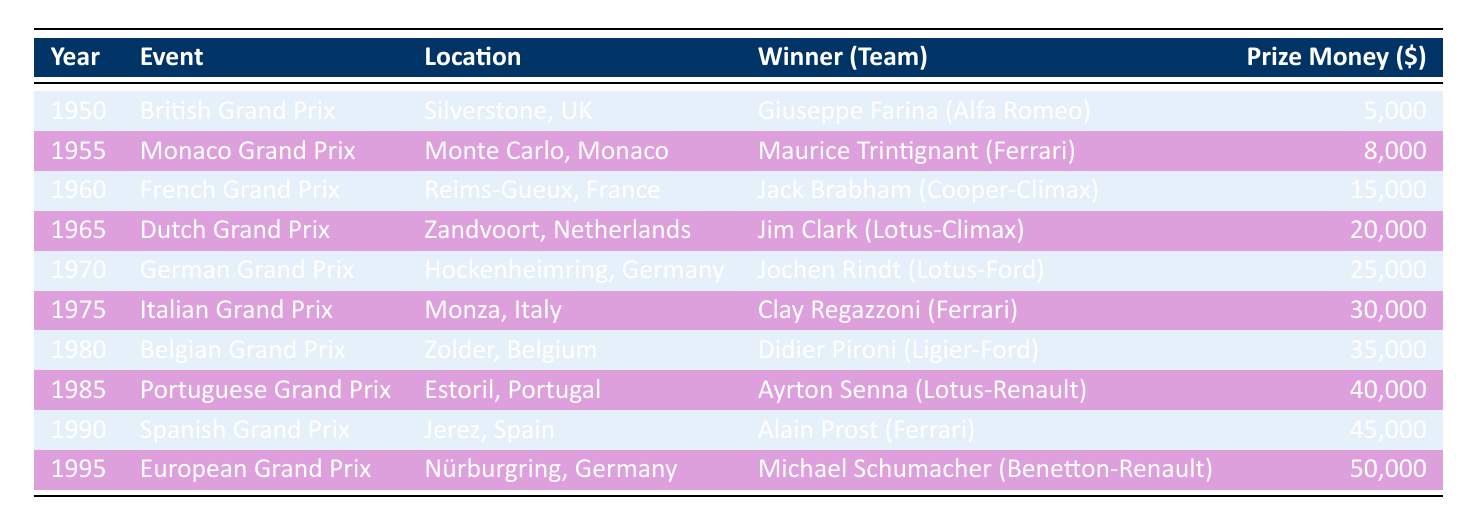What year did Giuseppe Farina win the British Grand Prix? The table indicates that Giuseppe Farina won the British Grand Prix in the year 1950.
Answer: 1950 Which event offered the highest prize money, and how much was it? By scanning the Prize Money column, the highest value is 50,000, which corresponds to the European Grand Prix in 1995.
Answer: European Grand Prix, 50000 What was the total prize money awarded for the events from 1950 to 1970? Adding the prize money from these years: 5000 + 8000 + 15000 + 20000 + 25000 = 70500. Therefore, the total prize money is 70500.
Answer: 70500 Did any winner from Ferrari claim a prize in 1985? The table shows that Ayrton Senna won the Portuguese Grand Prix in 1985, driving for Lotus-Renault, not Ferrari. Therefore, the answer is no.
Answer: No Which team had the winner in the 1975 Italian Grand Prix, and what was their prize money? The table shows that Clay Regazzoni, with Ferrari, won the 1975 Italian Grand Prix, earning a prize money of 30000.
Answer: Ferrari, 30000 What percentage increase in prize money was awarded from the 1960 French Grand Prix to the 1995 European Grand Prix? The prize money for the 1960 French Grand Prix was 15000, while for the 1995 European Grand Prix it was 50000. The increase is 50000 - 15000 = 35000. The percentage increase is (35000 / 15000) * 100 = 233.33%.
Answer: 233.33% Which race held in the 1960s had the prize money of 20000 and who was the winner? Looking in the table, the Dutch Grand Prix in 1965 had a prize money of 20000, and the winner was Jim Clark.
Answer: Dutch Grand Prix, Jim Clark What was the average prize money for the events held between 1950 and 1990? The prize money for these years is 5000 + 8000 + 15000 + 20000 + 25000 + 30000 + 35000 + 40000 + 45000 = 181000. There are 9 events, so the average is 181000 / 9 = 20111.11.
Answer: 20111.11 Did Jochen Rindt win the German Grand Prix in 1970? The table confirms that Jochen Rindt is listed as the winner of the German Grand Prix in 1970, hence the answer is yes.
Answer: Yes 